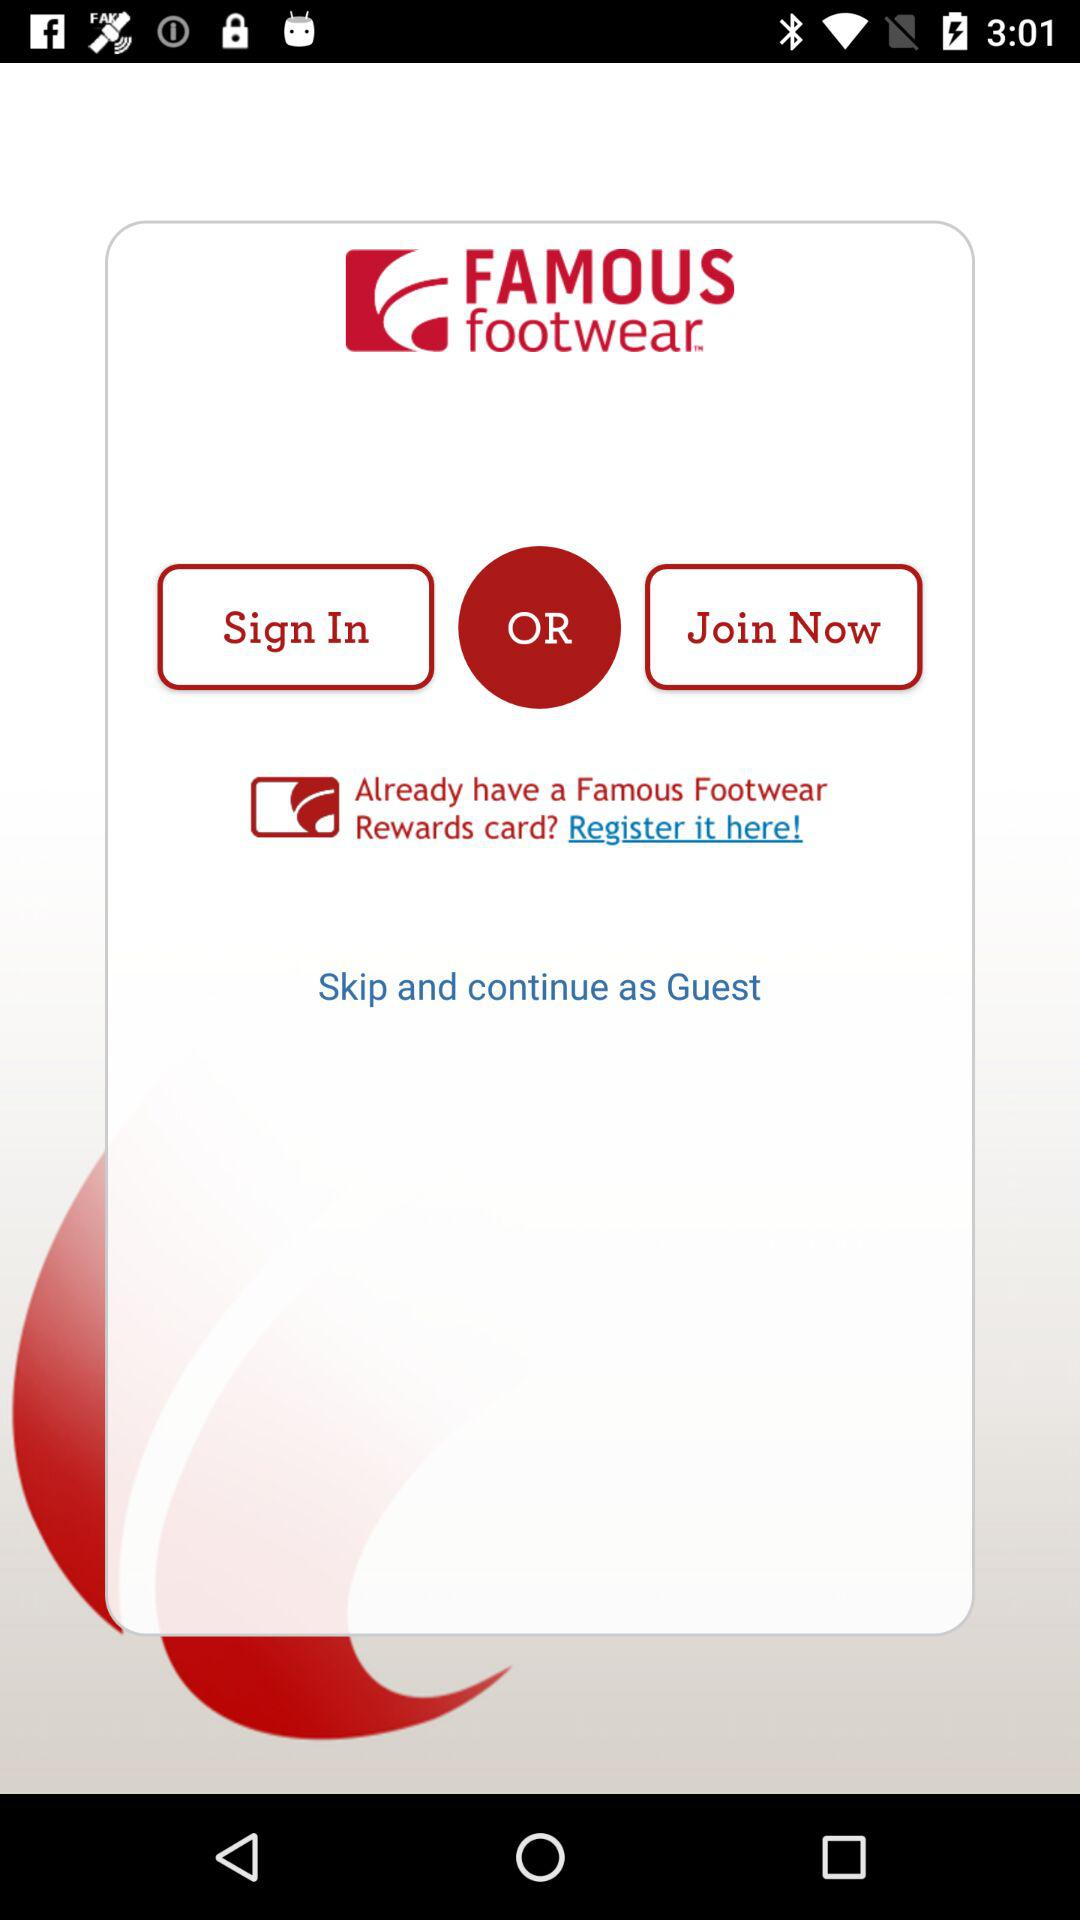Which are the 2 options? The two options are "Sign In" and "Join Now". 